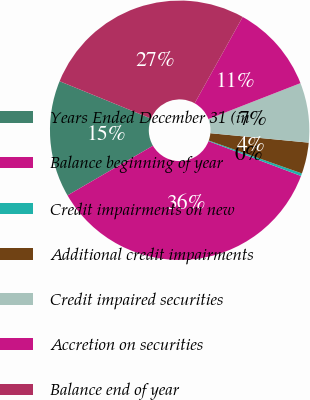Convert chart to OTSL. <chart><loc_0><loc_0><loc_500><loc_500><pie_chart><fcel>Years Ended December 31 (in<fcel>Balance beginning of year<fcel>Credit impairments on new<fcel>Additional credit impairments<fcel>Credit impaired securities<fcel>Accretion on securities<fcel>Balance end of year<nl><fcel>14.55%<fcel>35.89%<fcel>0.33%<fcel>3.88%<fcel>7.44%<fcel>11.0%<fcel>26.91%<nl></chart> 